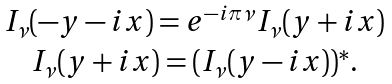<formula> <loc_0><loc_0><loc_500><loc_500>\begin{array} { c } I _ { \nu } ( - y - i x ) = e ^ { - i \pi \nu } I _ { \nu } ( y + i x ) \\ I _ { \nu } ( y + i x ) = ( I _ { \nu } ( y - i x ) ) ^ { * } . \end{array}</formula> 